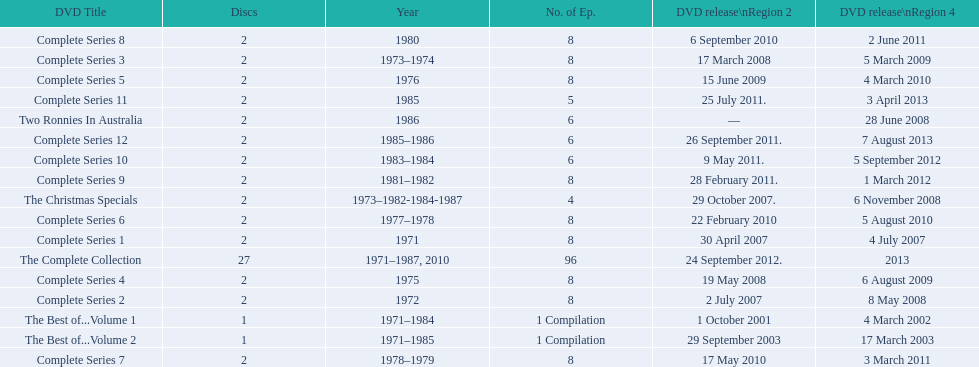Total number of episodes released in region 2 in 2007 20. 